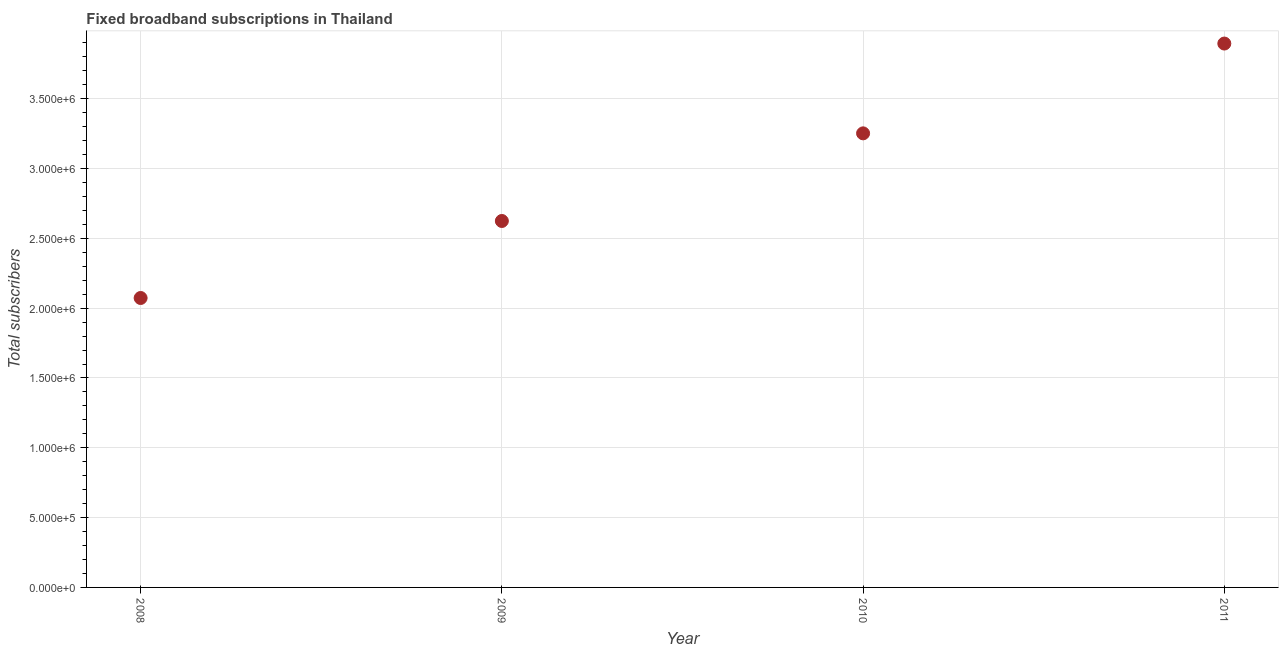What is the total number of fixed broadband subscriptions in 2008?
Your answer should be compact. 2.07e+06. Across all years, what is the maximum total number of fixed broadband subscriptions?
Ensure brevity in your answer.  3.90e+06. Across all years, what is the minimum total number of fixed broadband subscriptions?
Offer a terse response. 2.07e+06. What is the sum of the total number of fixed broadband subscriptions?
Make the answer very short. 1.18e+07. What is the difference between the total number of fixed broadband subscriptions in 2008 and 2010?
Keep it short and to the point. -1.18e+06. What is the average total number of fixed broadband subscriptions per year?
Provide a succinct answer. 2.96e+06. What is the median total number of fixed broadband subscriptions?
Keep it short and to the point. 2.94e+06. Do a majority of the years between 2010 and 2008 (inclusive) have total number of fixed broadband subscriptions greater than 1900000 ?
Your answer should be compact. No. What is the ratio of the total number of fixed broadband subscriptions in 2009 to that in 2011?
Provide a succinct answer. 0.67. Is the total number of fixed broadband subscriptions in 2009 less than that in 2011?
Offer a very short reply. Yes. What is the difference between the highest and the second highest total number of fixed broadband subscriptions?
Your answer should be compact. 6.43e+05. What is the difference between the highest and the lowest total number of fixed broadband subscriptions?
Ensure brevity in your answer.  1.82e+06. In how many years, is the total number of fixed broadband subscriptions greater than the average total number of fixed broadband subscriptions taken over all years?
Ensure brevity in your answer.  2. How many dotlines are there?
Make the answer very short. 1. How many years are there in the graph?
Your answer should be compact. 4. Does the graph contain any zero values?
Give a very brief answer. No. Does the graph contain grids?
Provide a succinct answer. Yes. What is the title of the graph?
Your answer should be very brief. Fixed broadband subscriptions in Thailand. What is the label or title of the X-axis?
Provide a succinct answer. Year. What is the label or title of the Y-axis?
Ensure brevity in your answer.  Total subscribers. What is the Total subscribers in 2008?
Provide a succinct answer. 2.07e+06. What is the Total subscribers in 2009?
Your answer should be very brief. 2.62e+06. What is the Total subscribers in 2010?
Make the answer very short. 3.25e+06. What is the Total subscribers in 2011?
Give a very brief answer. 3.90e+06. What is the difference between the Total subscribers in 2008 and 2009?
Your answer should be compact. -5.51e+05. What is the difference between the Total subscribers in 2008 and 2010?
Make the answer very short. -1.18e+06. What is the difference between the Total subscribers in 2008 and 2011?
Your answer should be very brief. -1.82e+06. What is the difference between the Total subscribers in 2009 and 2010?
Provide a succinct answer. -6.28e+05. What is the difference between the Total subscribers in 2009 and 2011?
Offer a terse response. -1.27e+06. What is the difference between the Total subscribers in 2010 and 2011?
Your answer should be very brief. -6.43e+05. What is the ratio of the Total subscribers in 2008 to that in 2009?
Your answer should be compact. 0.79. What is the ratio of the Total subscribers in 2008 to that in 2010?
Ensure brevity in your answer.  0.64. What is the ratio of the Total subscribers in 2008 to that in 2011?
Make the answer very short. 0.53. What is the ratio of the Total subscribers in 2009 to that in 2010?
Keep it short and to the point. 0.81. What is the ratio of the Total subscribers in 2009 to that in 2011?
Offer a terse response. 0.67. What is the ratio of the Total subscribers in 2010 to that in 2011?
Your response must be concise. 0.83. 